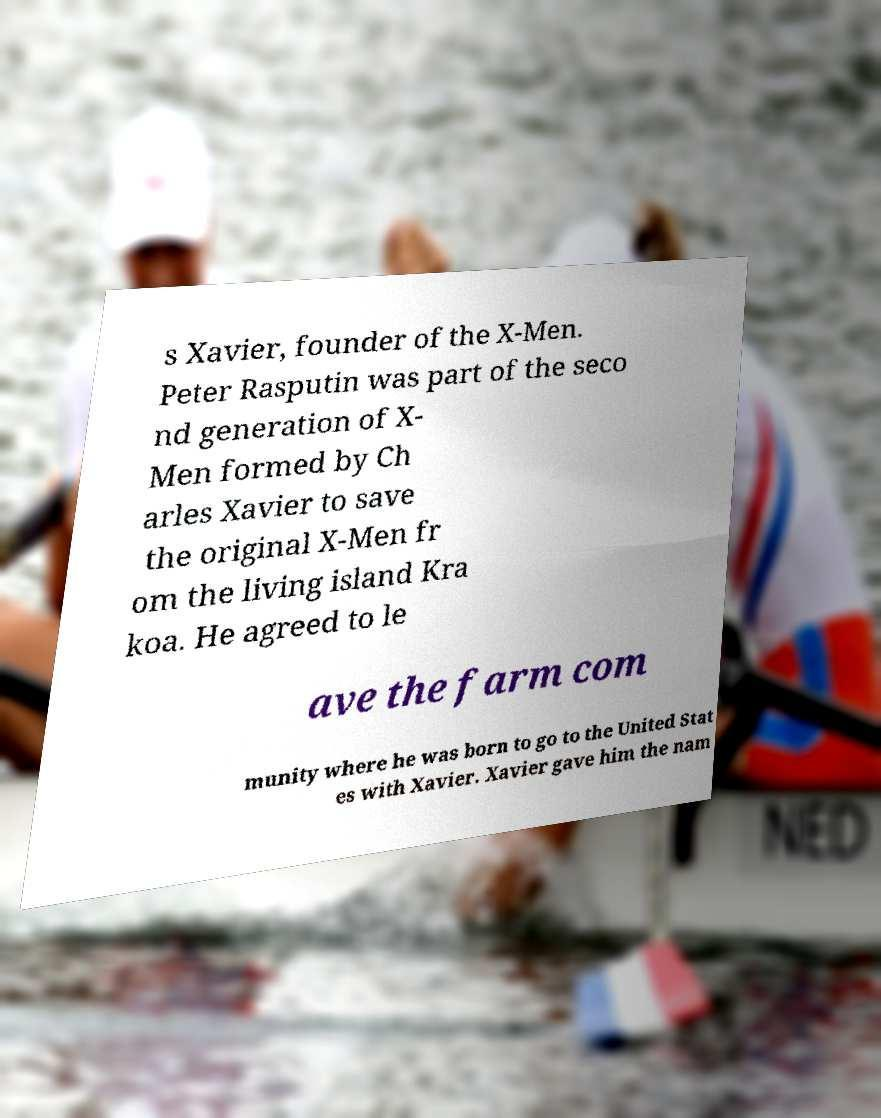Could you assist in decoding the text presented in this image and type it out clearly? s Xavier, founder of the X-Men. Peter Rasputin was part of the seco nd generation of X- Men formed by Ch arles Xavier to save the original X-Men fr om the living island Kra koa. He agreed to le ave the farm com munity where he was born to go to the United Stat es with Xavier. Xavier gave him the nam 